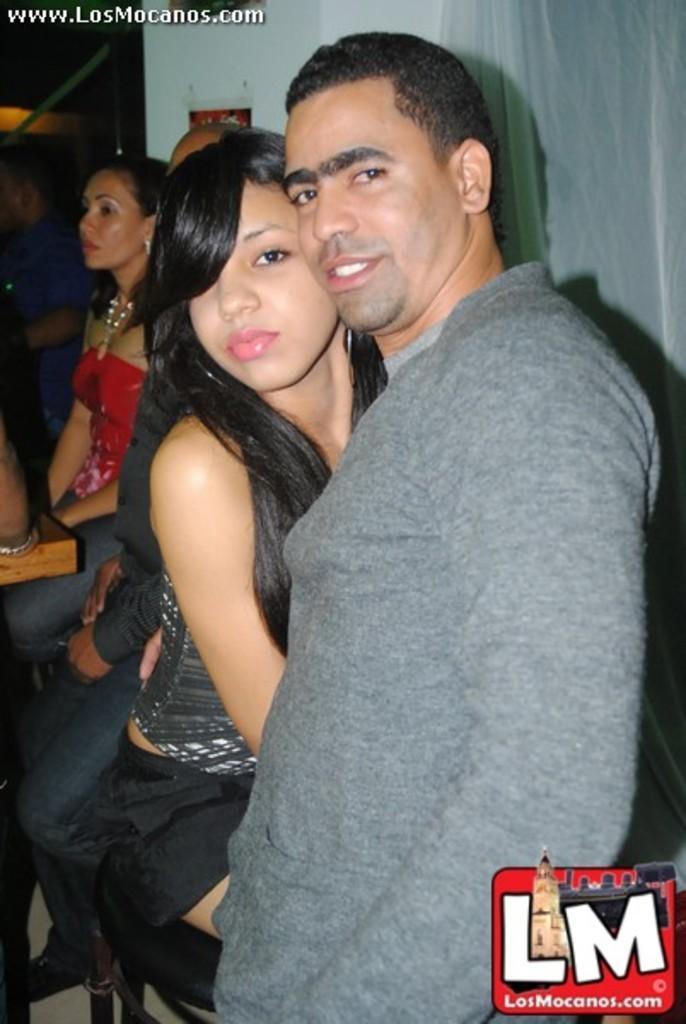Can you describe this image briefly? In this image we can see a group of people. On the backside we can see a curtain and a wall. 